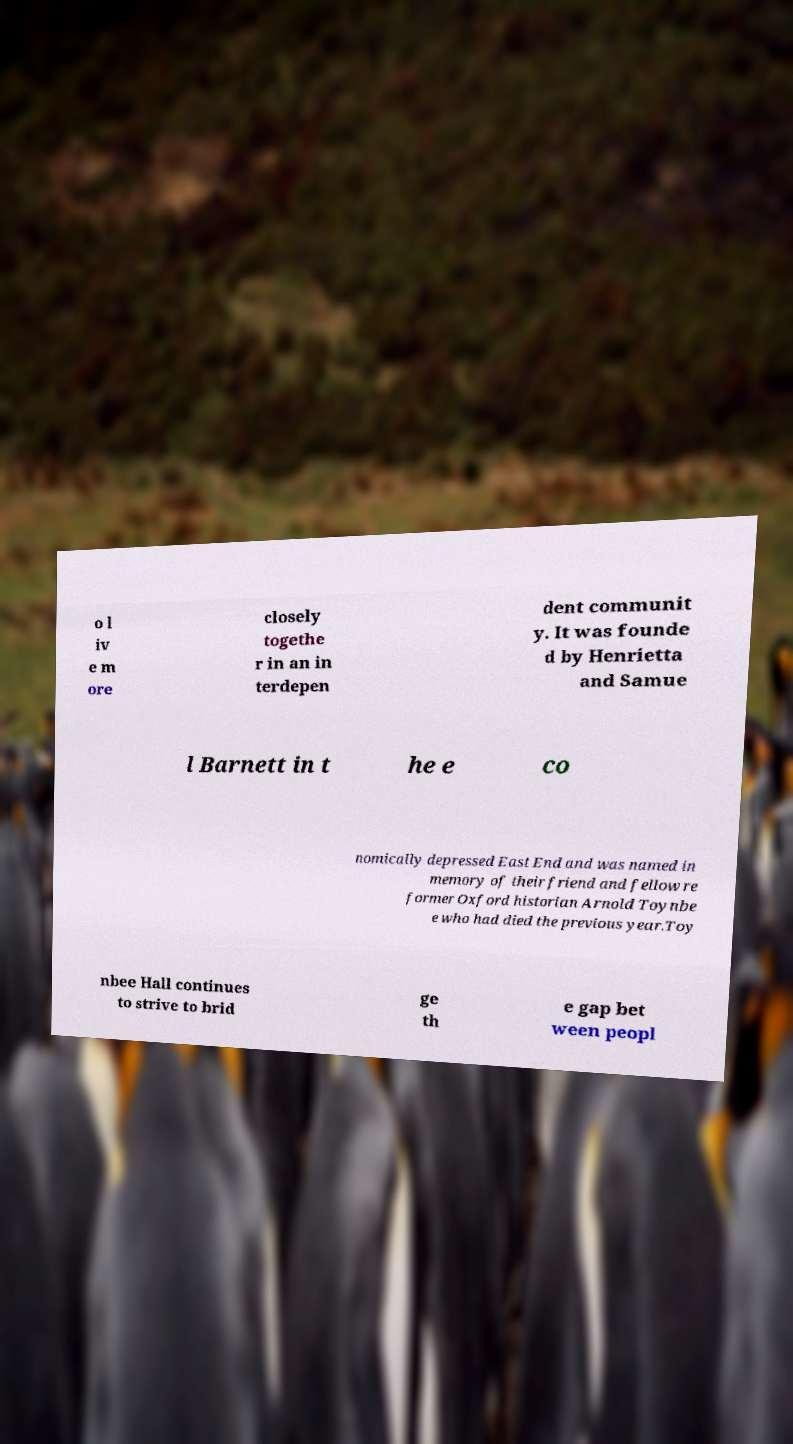Can you accurately transcribe the text from the provided image for me? o l iv e m ore closely togethe r in an in terdepen dent communit y. It was founde d by Henrietta and Samue l Barnett in t he e co nomically depressed East End and was named in memory of their friend and fellow re former Oxford historian Arnold Toynbe e who had died the previous year.Toy nbee Hall continues to strive to brid ge th e gap bet ween peopl 